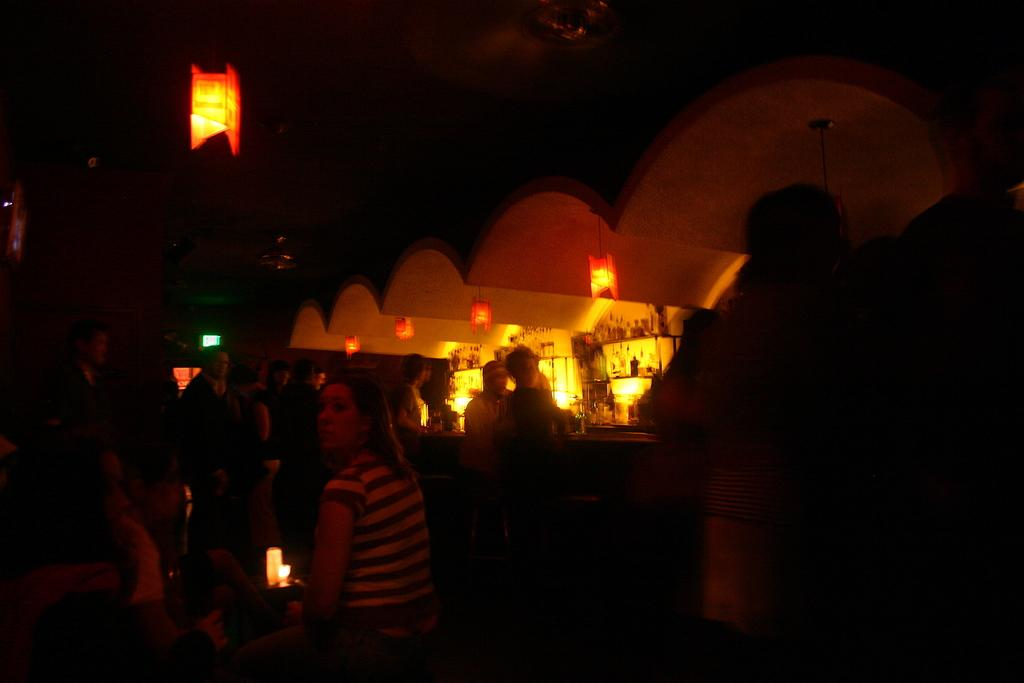What is the main subject of the image? There is a group of people in the image. What else can be seen in the image besides the people? There are lights, racks, and bottles in the image. Can you describe the lighting in the image? The lights are visible in the image. What is the color of the background in the image? The background is dark. How does the moon affect the temper of the people in the image? The image does not show the moon, and therefore it cannot be determined how the moon might affect the temper of the people in the image. 